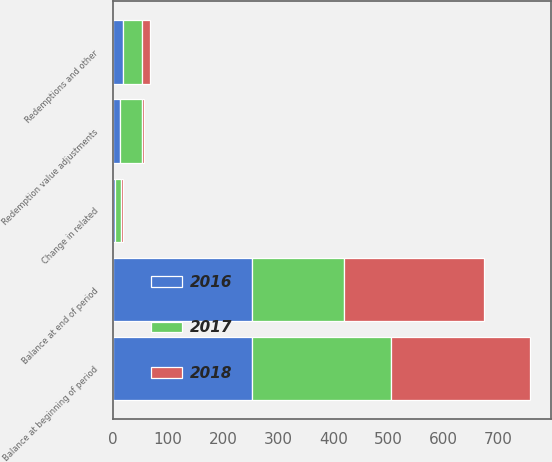Convert chart to OTSL. <chart><loc_0><loc_0><loc_500><loc_500><stacked_bar_chart><ecel><fcel>Balance at beginning of period<fcel>Change in related<fcel>Redemptions and other<fcel>Redemption value adjustments<fcel>Balance at end of period<nl><fcel>2017<fcel>252.1<fcel>10.7<fcel>33.7<fcel>39.8<fcel>167.9<nl><fcel>2016<fcel>252.8<fcel>2.8<fcel>18.5<fcel>12.9<fcel>252.1<nl><fcel>2018<fcel>251.9<fcel>4.9<fcel>14.8<fcel>4<fcel>252.8<nl></chart> 